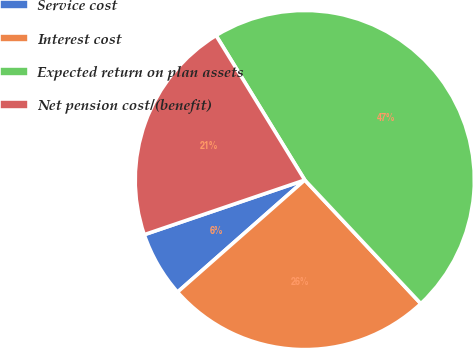Convert chart to OTSL. <chart><loc_0><loc_0><loc_500><loc_500><pie_chart><fcel>Service cost<fcel>Interest cost<fcel>Expected return on plan assets<fcel>Net pension cost/(benefit)<nl><fcel>6.27%<fcel>25.51%<fcel>46.77%<fcel>21.46%<nl></chart> 